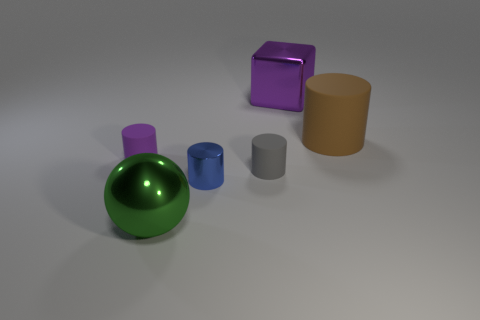Can you tell me what the different objects might represent in a symbolic way? Certainly! The sphere might symbolize completeness or unity, the cube could represent stability and permanence, and the cylinder might stand for continuity and expansion. Together, they could reflect different aspects of structure and flow in a system or idea. 
What are the possible materials for the other objects in the image? The sphere and the cylinders could be made of painted ceramics or plastic due to their glossy finish, and the smaller blue cylinder might be metallic or glass because of its reflective properties. The lavender cube's slight reflections hint at a hard surface, possibly plastic or painted metal. 